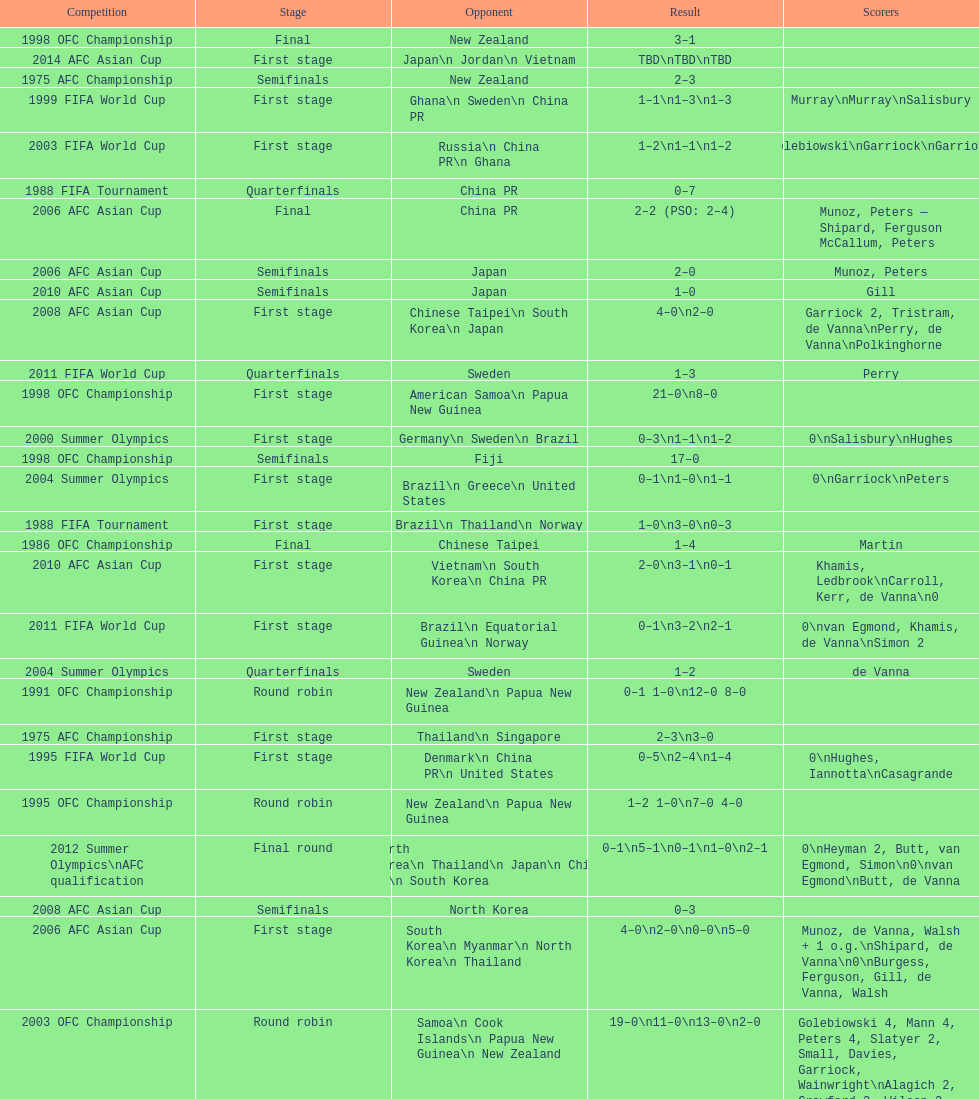Who was the last opponent this team faced in the 2010 afc asian cup? North Korea. 